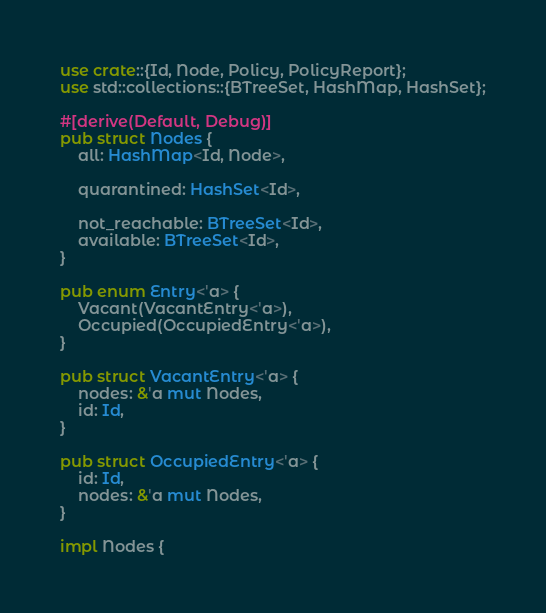Convert code to text. <code><loc_0><loc_0><loc_500><loc_500><_Rust_>use crate::{Id, Node, Policy, PolicyReport};
use std::collections::{BTreeSet, HashMap, HashSet};

#[derive(Default, Debug)]
pub struct Nodes {
    all: HashMap<Id, Node>,

    quarantined: HashSet<Id>,

    not_reachable: BTreeSet<Id>,
    available: BTreeSet<Id>,
}

pub enum Entry<'a> {
    Vacant(VacantEntry<'a>),
    Occupied(OccupiedEntry<'a>),
}

pub struct VacantEntry<'a> {
    nodes: &'a mut Nodes,
    id: Id,
}

pub struct OccupiedEntry<'a> {
    id: Id,
    nodes: &'a mut Nodes,
}

impl Nodes {</code> 